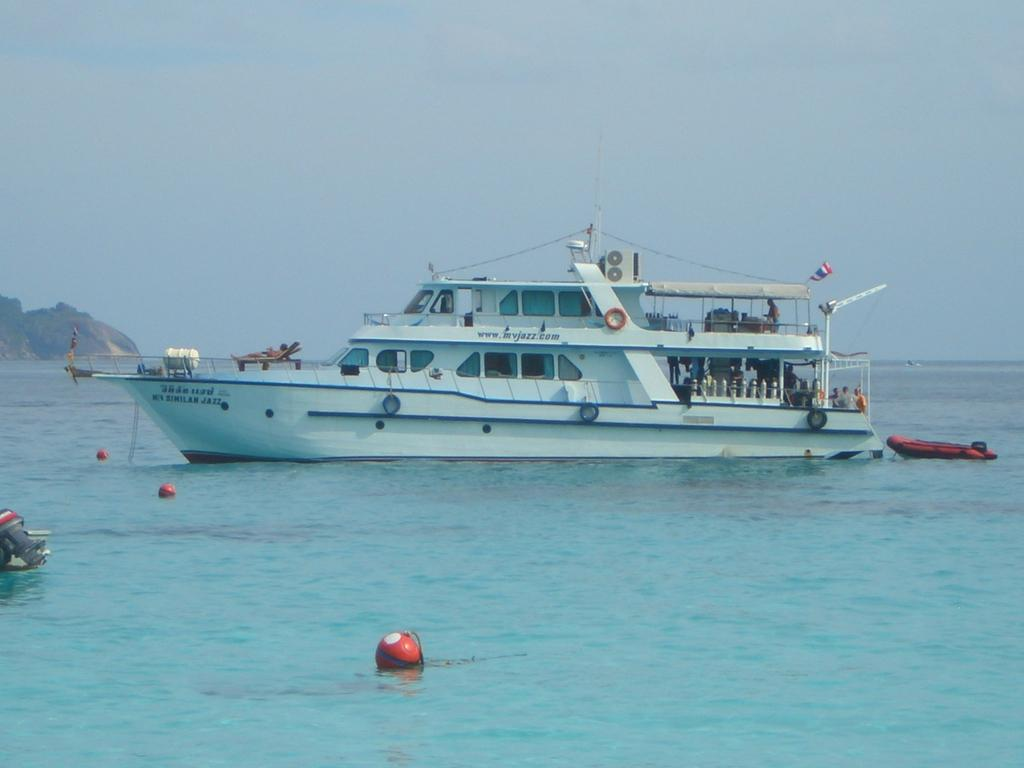What is the main subject of the image? The main subject of the image is a ship sailing. Where is the ship located? The ship is on the sea. What can be seen on the left side of the image? There is a rock hill on the left side of the image. What is visible in the background of the image? The sky is visible in the background of the image. Can you tell me how many bells are hanging from the ship's mast in the image? There are no bells visible on the ship's mast in the image. Is there a baby on board the ship in the image? There is no indication of a baby or any people on board the ship in the image. 